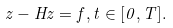Convert formula to latex. <formula><loc_0><loc_0><loc_500><loc_500>z - H z = f , t \in [ 0 , T ] .</formula> 